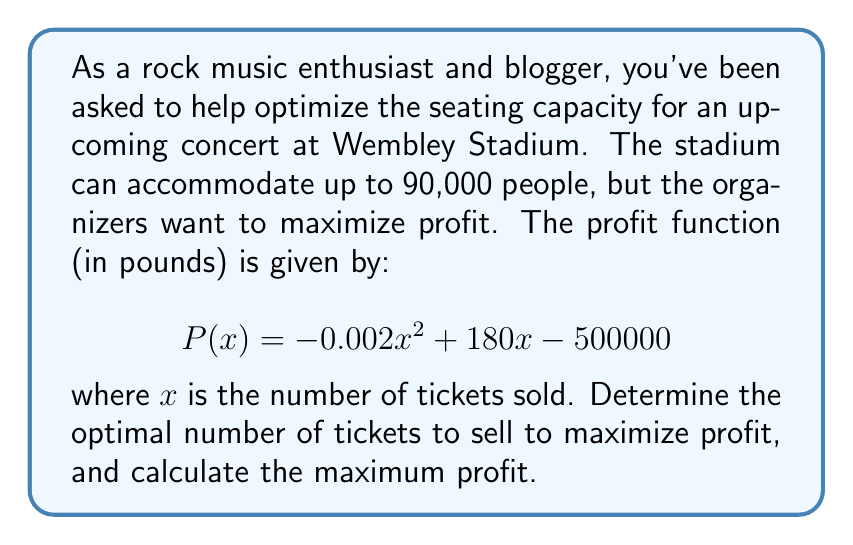Show me your answer to this math problem. To solve this optimization problem, we need to follow these steps:

1. Identify the profit function:
   $$P(x) = -0.002x^2 + 180x - 500000$$

2. Find the derivative of the profit function:
   $$P'(x) = -0.004x + 180$$

3. Set the derivative equal to zero and solve for x:
   $$-0.004x + 180 = 0$$
   $$-0.004x = -180$$
   $$x = 45000$$

4. Verify that this critical point is a maximum by checking the second derivative:
   $$P''(x) = -0.004$$
   Since $P''(x)$ is negative, the critical point is a maximum.

5. Calculate the maximum profit by plugging x = 45000 into the original profit function:
   $$P(45000) = -0.002(45000)^2 + 180(45000) - 500000$$
   $$= -4050000 + 8100000 - 500000$$
   $$= 3550000$$

Therefore, the optimal number of tickets to sell is 45,000, and the maximum profit is £3,550,000.
Answer: Optimal number of tickets: 45,000
Maximum profit: £3,550,000 